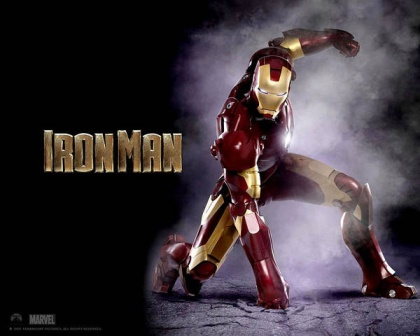Describe a day in the life of Tony Stark while wearing the Iron Man suit. Tony Stark starts his day with a briefing from JARVIS, his AI assistant, about the current state of global affairs and any threats that need his attention. He suits up in the Iron Man armor, and performs a series of diagnostics and tests on the suit’s systems. Throughout the day, Tony attends high-level meetings with government officials and other superheroes, responding to any immediate crises that arise. Using the suit's advanced communication systems, he coordinates missions and provides aid to those in need. In between saving the world, Tony might work on upgrading the suit or developing new technologies in his lab. At the end of the day, he might unwind by flying around the city, enjoying the view from above, and ensuring the safety of his home turf. 